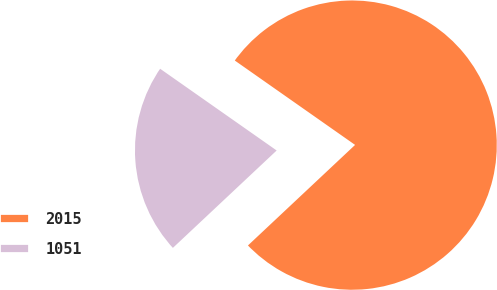Convert chart to OTSL. <chart><loc_0><loc_0><loc_500><loc_500><pie_chart><fcel>2015<fcel>1051<nl><fcel>78.27%<fcel>21.73%<nl></chart> 